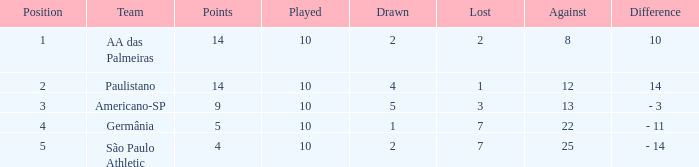What is the total of against when the loss exceeds 7? None. 